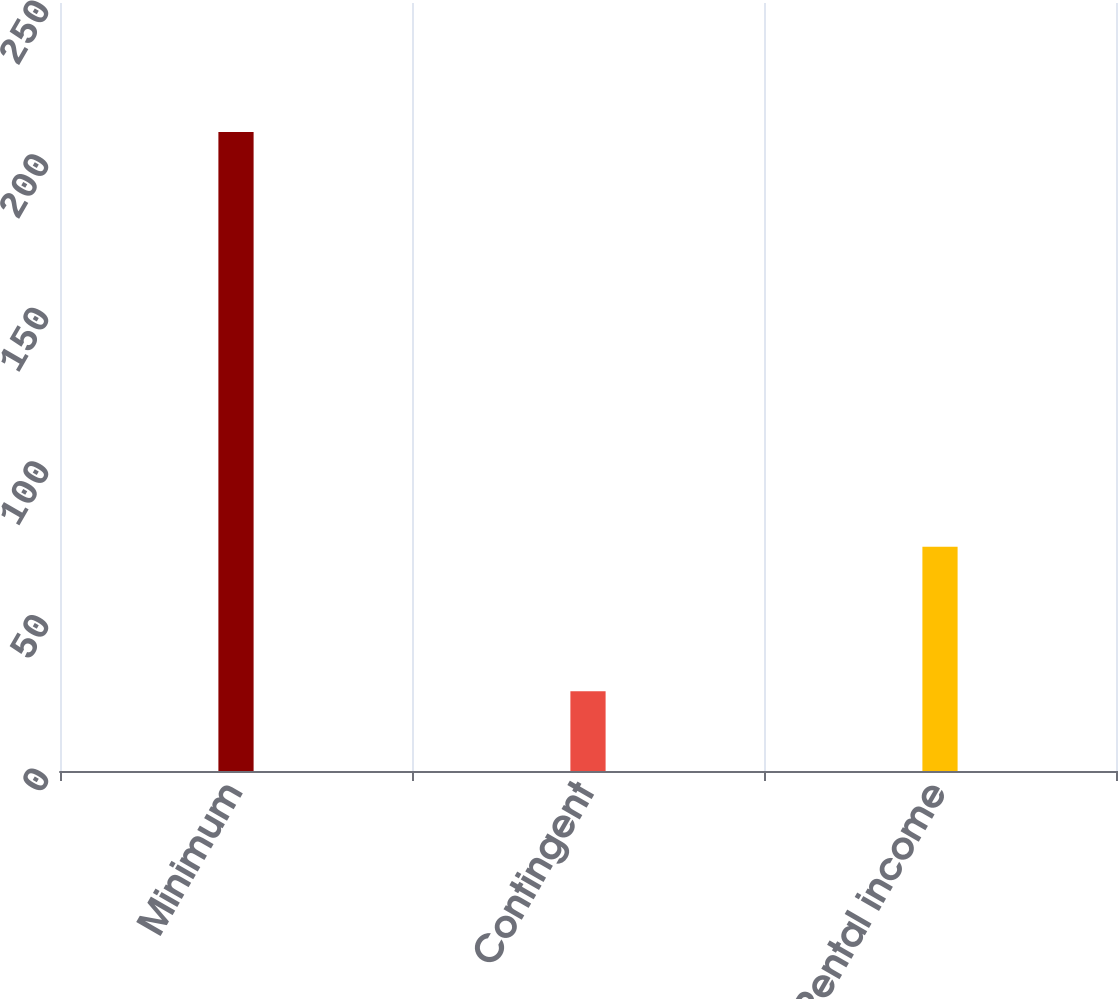<chart> <loc_0><loc_0><loc_500><loc_500><bar_chart><fcel>Minimum<fcel>Contingent<fcel>Rental income<nl><fcel>208<fcel>26<fcel>73<nl></chart> 